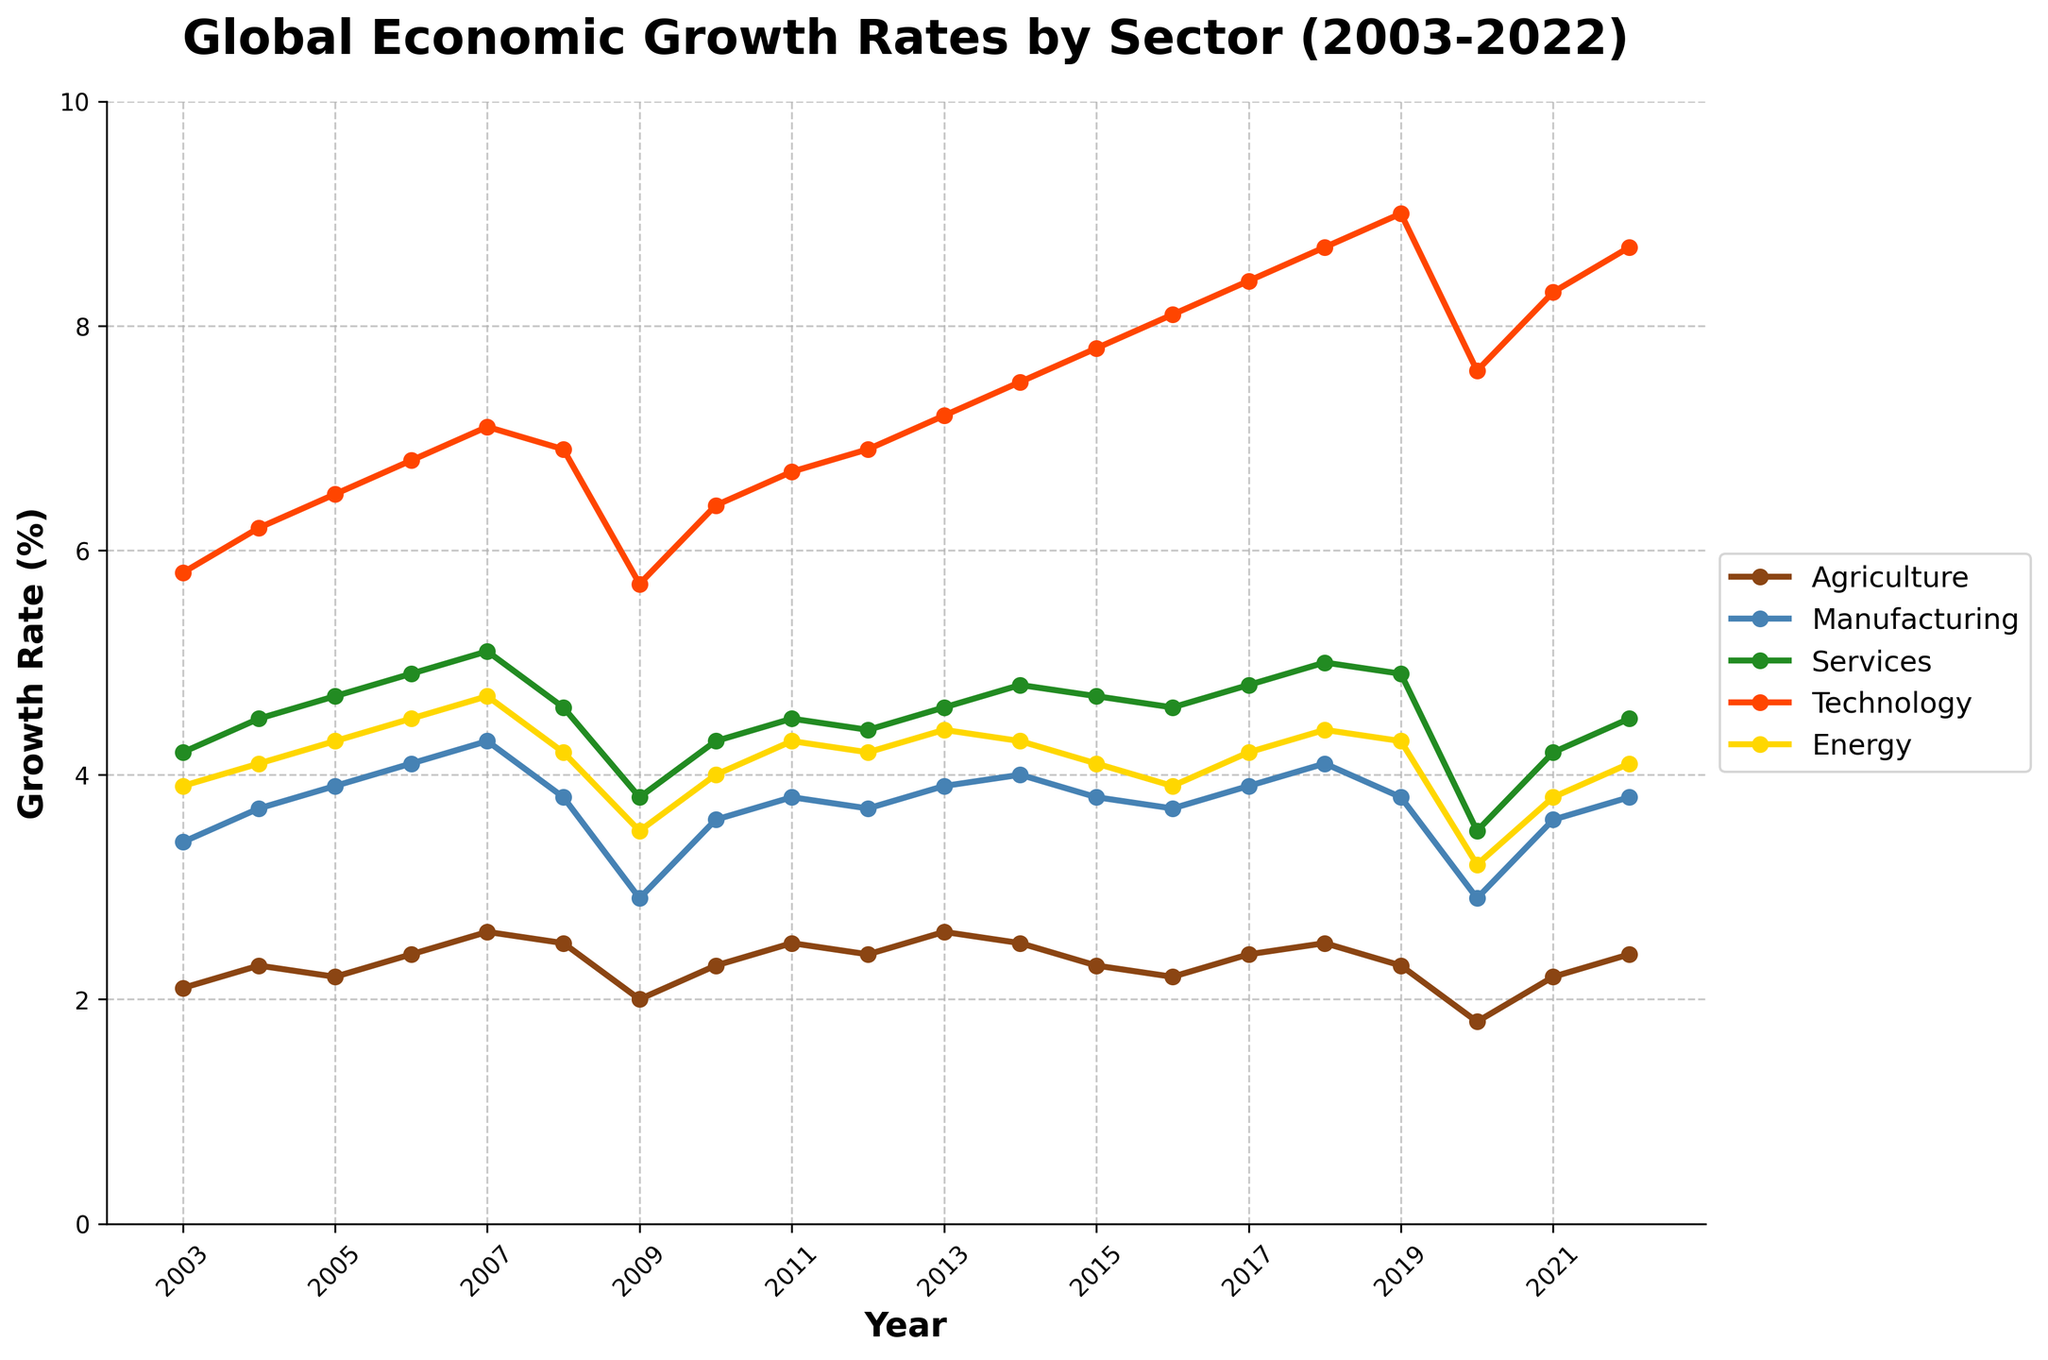Which sector experienced the highest growth rate in 2022? First, identify the data for 2022 from the figure. Next, compare the growth rates of all the sectors in that year. The sector with the highest growth rate is the one you're looking for.
Answer: Technology How did the growth rate of the Agriculture sector change from 2009 to 2010? Identify the data points for the Agriculture sector for both years from the figure. Subtract the 2009 value (2.0) from the 2010 value (2.3) to find the change.
Answer: Increased by 0.3 What is the average growth rate of the Services sector over the entire period from 2003 to 2022? Extract the data points for the Services sector for each year from the figure. Add these values together and divide by the total number of years (20) to calculate the average.
Answer: 4.6% Which sector had the lowest growth rate during the global financial crisis in 2009? Identify the data points for 2009 from the figure for all sectors. The sector with the lowest growth rate in that year is the one you're looking for.
Answer: Agriculture By how much did the growth rate of the Technology sector drop from 2019 to 2020? Identify the values for the Technology sector in 2019 (9.0) and 2020 (7.6) from the figure. Subtract the 2020 value from the 2019 value to find the decrease.
Answer: 1.4 Between which consecutive years did the Manufacturing sector experience the largest increase in growth rate? Identify the year-to-year changes for the Manufacturing sector from the figure, then find the largest increase by comparing these differences.
Answer: 2006 to 2007 Compare the growth rate trends of the Energy and Agriculture sectors from 2015 to 2020. Which sector showed greater variability? Identify the data points for both sectors from 2015 to 2020 in the figure. Calculate the variability by examining the range or standard deviation of the growth rates for both sectors.
Answer: Energy What is the overall trend of the growth rate for the Technology sector from 2003 to 2022? Observe the data points for the Technology sector for each year in the figure and describe the general direction (increasing, decreasing, or fluctuating).
Answer: Increasing How does the growth rate of the Energy sector in 2022 compare to its rate in 2003? Identify the values for the Energy sector in 2003 and 2022 from the figure. Subtract the 2003 value from the 2022 value to determine the difference.
Answer: Increased by 0.2 What is the median growth rate of the Services sector over the given period? Extract the data points for the Services sector for all years from the figure, then order them from smallest to largest and find the middle value.
Answer: 4.6% 